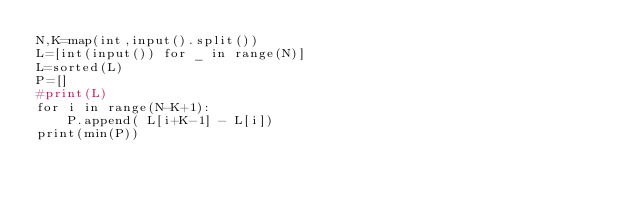Convert code to text. <code><loc_0><loc_0><loc_500><loc_500><_Python_>N,K=map(int,input().split())
L=[int(input()) for _ in range(N)]
L=sorted(L)
P=[]
#print(L)
for i in range(N-K+1):
    P.append( L[i+K-1] - L[i])
print(min(P))
</code> 